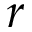Convert formula to latex. <formula><loc_0><loc_0><loc_500><loc_500>r</formula> 